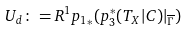Convert formula to latex. <formula><loc_0><loc_0><loc_500><loc_500>U _ { d } \colon = R ^ { 1 } { p _ { 1 } } _ { * } ( p _ { 3 } ^ { * } ( T _ { X } | C ) | _ { \overline { \Gamma } } )</formula> 